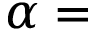Convert formula to latex. <formula><loc_0><loc_0><loc_500><loc_500>\alpha =</formula> 